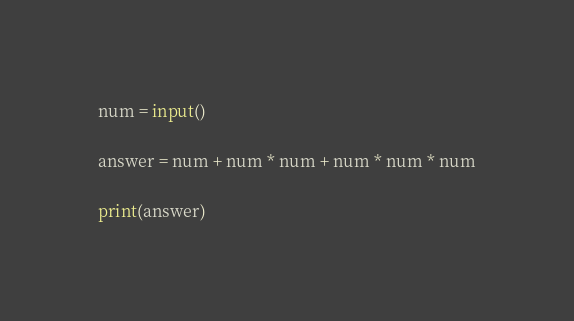<code> <loc_0><loc_0><loc_500><loc_500><_Python_>num = input()
 
answer = num + num * num + num * num * num

print(answer)</code> 